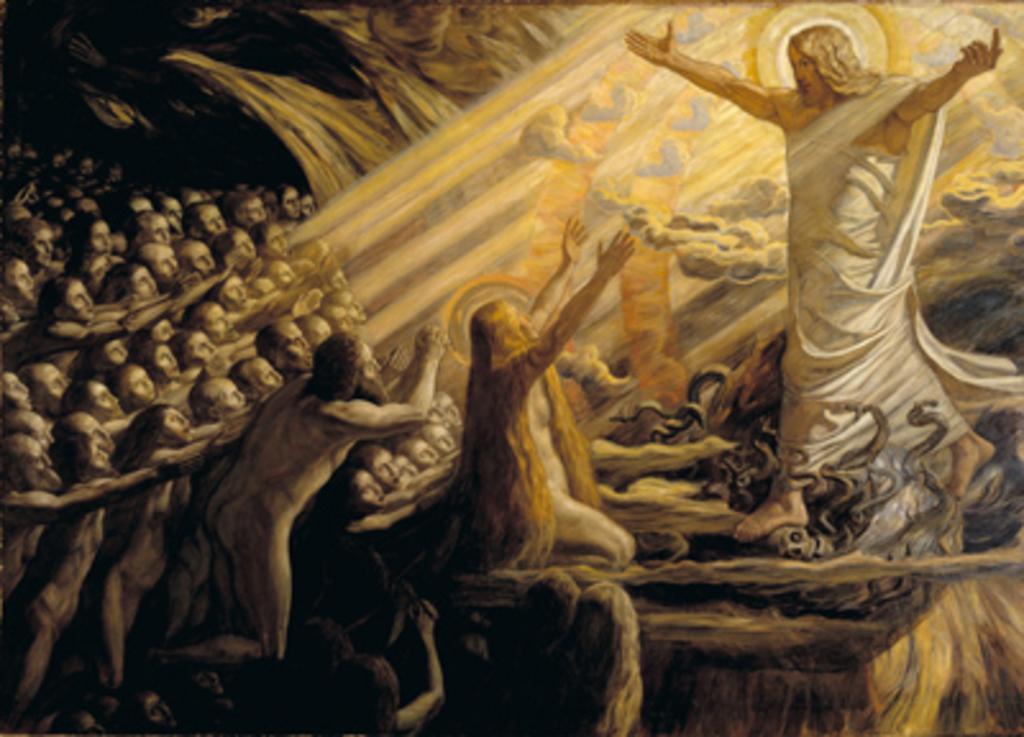Can you describe this image briefly? This is a painting and in this painting we can see a group of people and some objects. 